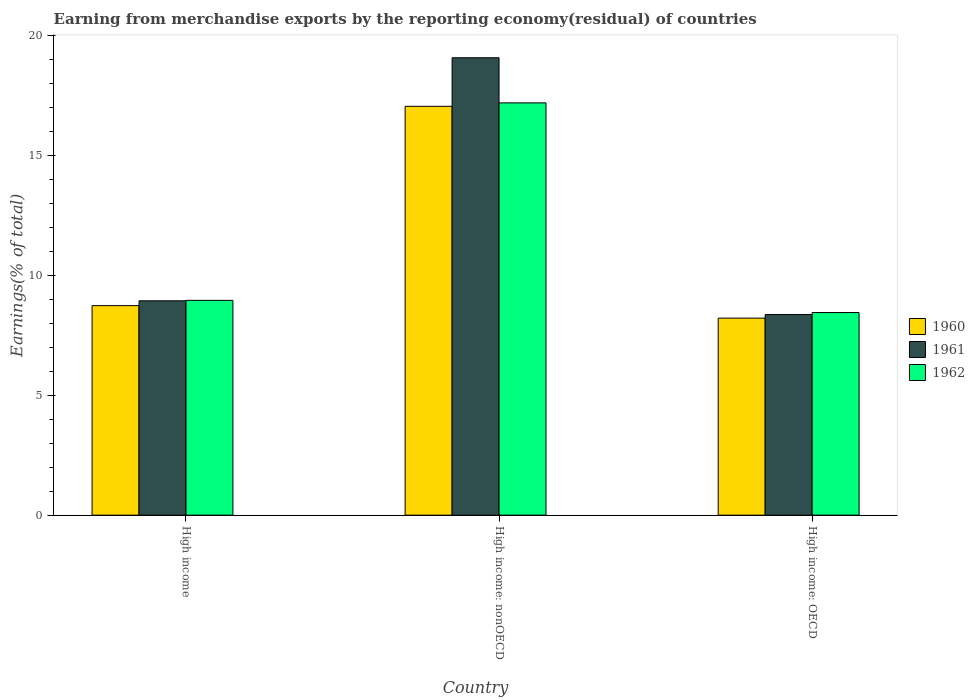How many groups of bars are there?
Offer a very short reply. 3. Are the number of bars per tick equal to the number of legend labels?
Provide a short and direct response. Yes. How many bars are there on the 3rd tick from the right?
Keep it short and to the point. 3. What is the label of the 2nd group of bars from the left?
Give a very brief answer. High income: nonOECD. In how many cases, is the number of bars for a given country not equal to the number of legend labels?
Your answer should be very brief. 0. What is the percentage of amount earned from merchandise exports in 1962 in High income: OECD?
Your answer should be very brief. 8.44. Across all countries, what is the maximum percentage of amount earned from merchandise exports in 1962?
Provide a succinct answer. 17.18. Across all countries, what is the minimum percentage of amount earned from merchandise exports in 1961?
Offer a terse response. 8.36. In which country was the percentage of amount earned from merchandise exports in 1960 maximum?
Provide a succinct answer. High income: nonOECD. In which country was the percentage of amount earned from merchandise exports in 1962 minimum?
Keep it short and to the point. High income: OECD. What is the total percentage of amount earned from merchandise exports in 1961 in the graph?
Your answer should be very brief. 36.36. What is the difference between the percentage of amount earned from merchandise exports in 1962 in High income and that in High income: OECD?
Offer a very short reply. 0.51. What is the difference between the percentage of amount earned from merchandise exports in 1961 in High income: nonOECD and the percentage of amount earned from merchandise exports in 1962 in High income?
Provide a short and direct response. 10.11. What is the average percentage of amount earned from merchandise exports in 1962 per country?
Your answer should be very brief. 11.53. What is the difference between the percentage of amount earned from merchandise exports of/in 1961 and percentage of amount earned from merchandise exports of/in 1960 in High income: nonOECD?
Your answer should be compact. 2.02. What is the ratio of the percentage of amount earned from merchandise exports in 1960 in High income to that in High income: nonOECD?
Provide a short and direct response. 0.51. Is the percentage of amount earned from merchandise exports in 1961 in High income less than that in High income: nonOECD?
Ensure brevity in your answer.  Yes. Is the difference between the percentage of amount earned from merchandise exports in 1961 in High income: OECD and High income: nonOECD greater than the difference between the percentage of amount earned from merchandise exports in 1960 in High income: OECD and High income: nonOECD?
Your answer should be compact. No. What is the difference between the highest and the second highest percentage of amount earned from merchandise exports in 1962?
Offer a terse response. -8.23. What is the difference between the highest and the lowest percentage of amount earned from merchandise exports in 1960?
Provide a short and direct response. 8.83. In how many countries, is the percentage of amount earned from merchandise exports in 1962 greater than the average percentage of amount earned from merchandise exports in 1962 taken over all countries?
Offer a very short reply. 1. Does the graph contain any zero values?
Keep it short and to the point. No. Where does the legend appear in the graph?
Keep it short and to the point. Center right. How many legend labels are there?
Provide a succinct answer. 3. How are the legend labels stacked?
Keep it short and to the point. Vertical. What is the title of the graph?
Provide a succinct answer. Earning from merchandise exports by the reporting economy(residual) of countries. What is the label or title of the Y-axis?
Give a very brief answer. Earnings(% of total). What is the Earnings(% of total) of 1960 in High income?
Offer a terse response. 8.73. What is the Earnings(% of total) in 1961 in High income?
Keep it short and to the point. 8.93. What is the Earnings(% of total) of 1962 in High income?
Make the answer very short. 8.95. What is the Earnings(% of total) of 1960 in High income: nonOECD?
Keep it short and to the point. 17.04. What is the Earnings(% of total) in 1961 in High income: nonOECD?
Offer a very short reply. 19.06. What is the Earnings(% of total) of 1962 in High income: nonOECD?
Make the answer very short. 17.18. What is the Earnings(% of total) in 1960 in High income: OECD?
Offer a terse response. 8.21. What is the Earnings(% of total) in 1961 in High income: OECD?
Provide a succinct answer. 8.36. What is the Earnings(% of total) in 1962 in High income: OECD?
Make the answer very short. 8.44. Across all countries, what is the maximum Earnings(% of total) of 1960?
Your answer should be very brief. 17.04. Across all countries, what is the maximum Earnings(% of total) of 1961?
Offer a very short reply. 19.06. Across all countries, what is the maximum Earnings(% of total) in 1962?
Your answer should be compact. 17.18. Across all countries, what is the minimum Earnings(% of total) of 1960?
Offer a very short reply. 8.21. Across all countries, what is the minimum Earnings(% of total) in 1961?
Your answer should be very brief. 8.36. Across all countries, what is the minimum Earnings(% of total) in 1962?
Make the answer very short. 8.44. What is the total Earnings(% of total) of 1960 in the graph?
Your answer should be very brief. 33.98. What is the total Earnings(% of total) of 1961 in the graph?
Provide a succinct answer. 36.36. What is the total Earnings(% of total) in 1962 in the graph?
Your answer should be very brief. 34.58. What is the difference between the Earnings(% of total) of 1960 in High income and that in High income: nonOECD?
Offer a terse response. -8.31. What is the difference between the Earnings(% of total) of 1961 in High income and that in High income: nonOECD?
Offer a very short reply. -10.13. What is the difference between the Earnings(% of total) in 1962 in High income and that in High income: nonOECD?
Make the answer very short. -8.23. What is the difference between the Earnings(% of total) in 1960 in High income and that in High income: OECD?
Offer a terse response. 0.52. What is the difference between the Earnings(% of total) of 1961 in High income and that in High income: OECD?
Make the answer very short. 0.57. What is the difference between the Earnings(% of total) in 1962 in High income and that in High income: OECD?
Your answer should be very brief. 0.51. What is the difference between the Earnings(% of total) of 1960 in High income: nonOECD and that in High income: OECD?
Offer a very short reply. 8.83. What is the difference between the Earnings(% of total) in 1961 in High income: nonOECD and that in High income: OECD?
Make the answer very short. 10.7. What is the difference between the Earnings(% of total) of 1962 in High income: nonOECD and that in High income: OECD?
Provide a short and direct response. 8.74. What is the difference between the Earnings(% of total) in 1960 in High income and the Earnings(% of total) in 1961 in High income: nonOECD?
Your response must be concise. -10.33. What is the difference between the Earnings(% of total) of 1960 in High income and the Earnings(% of total) of 1962 in High income: nonOECD?
Provide a short and direct response. -8.45. What is the difference between the Earnings(% of total) of 1961 in High income and the Earnings(% of total) of 1962 in High income: nonOECD?
Make the answer very short. -8.25. What is the difference between the Earnings(% of total) of 1960 in High income and the Earnings(% of total) of 1961 in High income: OECD?
Give a very brief answer. 0.37. What is the difference between the Earnings(% of total) of 1960 in High income and the Earnings(% of total) of 1962 in High income: OECD?
Offer a terse response. 0.29. What is the difference between the Earnings(% of total) of 1961 in High income and the Earnings(% of total) of 1962 in High income: OECD?
Keep it short and to the point. 0.49. What is the difference between the Earnings(% of total) in 1960 in High income: nonOECD and the Earnings(% of total) in 1961 in High income: OECD?
Make the answer very short. 8.68. What is the difference between the Earnings(% of total) in 1960 in High income: nonOECD and the Earnings(% of total) in 1962 in High income: OECD?
Give a very brief answer. 8.6. What is the difference between the Earnings(% of total) of 1961 in High income: nonOECD and the Earnings(% of total) of 1962 in High income: OECD?
Keep it short and to the point. 10.62. What is the average Earnings(% of total) of 1960 per country?
Offer a terse response. 11.33. What is the average Earnings(% of total) in 1961 per country?
Your answer should be compact. 12.12. What is the average Earnings(% of total) in 1962 per country?
Provide a succinct answer. 11.53. What is the difference between the Earnings(% of total) of 1960 and Earnings(% of total) of 1961 in High income?
Your answer should be very brief. -0.2. What is the difference between the Earnings(% of total) in 1960 and Earnings(% of total) in 1962 in High income?
Give a very brief answer. -0.22. What is the difference between the Earnings(% of total) in 1961 and Earnings(% of total) in 1962 in High income?
Offer a very short reply. -0.02. What is the difference between the Earnings(% of total) in 1960 and Earnings(% of total) in 1961 in High income: nonOECD?
Give a very brief answer. -2.02. What is the difference between the Earnings(% of total) in 1960 and Earnings(% of total) in 1962 in High income: nonOECD?
Your answer should be compact. -0.14. What is the difference between the Earnings(% of total) in 1961 and Earnings(% of total) in 1962 in High income: nonOECD?
Offer a very short reply. 1.88. What is the difference between the Earnings(% of total) in 1960 and Earnings(% of total) in 1961 in High income: OECD?
Ensure brevity in your answer.  -0.15. What is the difference between the Earnings(% of total) in 1960 and Earnings(% of total) in 1962 in High income: OECD?
Offer a terse response. -0.23. What is the difference between the Earnings(% of total) of 1961 and Earnings(% of total) of 1962 in High income: OECD?
Offer a very short reply. -0.08. What is the ratio of the Earnings(% of total) in 1960 in High income to that in High income: nonOECD?
Ensure brevity in your answer.  0.51. What is the ratio of the Earnings(% of total) of 1961 in High income to that in High income: nonOECD?
Give a very brief answer. 0.47. What is the ratio of the Earnings(% of total) of 1962 in High income to that in High income: nonOECD?
Your answer should be very brief. 0.52. What is the ratio of the Earnings(% of total) of 1960 in High income to that in High income: OECD?
Give a very brief answer. 1.06. What is the ratio of the Earnings(% of total) in 1961 in High income to that in High income: OECD?
Your response must be concise. 1.07. What is the ratio of the Earnings(% of total) of 1962 in High income to that in High income: OECD?
Provide a short and direct response. 1.06. What is the ratio of the Earnings(% of total) in 1960 in High income: nonOECD to that in High income: OECD?
Ensure brevity in your answer.  2.08. What is the ratio of the Earnings(% of total) of 1961 in High income: nonOECD to that in High income: OECD?
Ensure brevity in your answer.  2.28. What is the ratio of the Earnings(% of total) in 1962 in High income: nonOECD to that in High income: OECD?
Give a very brief answer. 2.03. What is the difference between the highest and the second highest Earnings(% of total) of 1960?
Offer a very short reply. 8.31. What is the difference between the highest and the second highest Earnings(% of total) of 1961?
Your response must be concise. 10.13. What is the difference between the highest and the second highest Earnings(% of total) in 1962?
Your response must be concise. 8.23. What is the difference between the highest and the lowest Earnings(% of total) in 1960?
Offer a terse response. 8.83. What is the difference between the highest and the lowest Earnings(% of total) of 1961?
Ensure brevity in your answer.  10.7. What is the difference between the highest and the lowest Earnings(% of total) in 1962?
Your response must be concise. 8.74. 